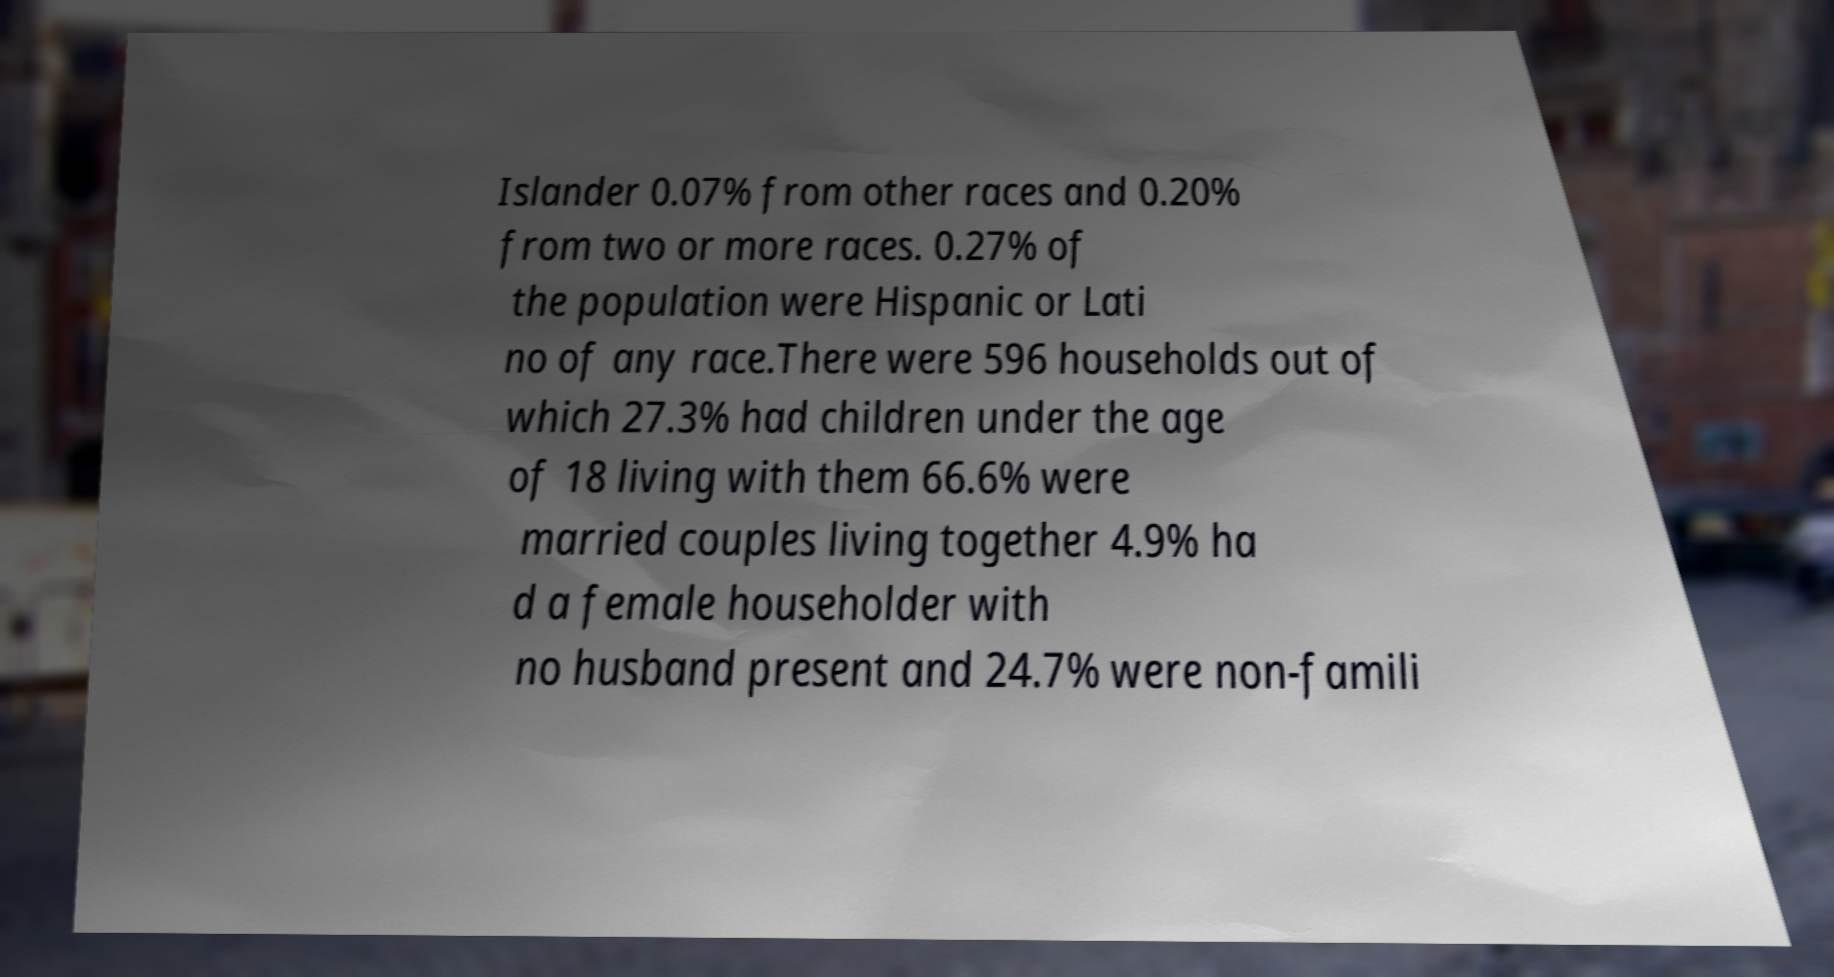Please identify and transcribe the text found in this image. Islander 0.07% from other races and 0.20% from two or more races. 0.27% of the population were Hispanic or Lati no of any race.There were 596 households out of which 27.3% had children under the age of 18 living with them 66.6% were married couples living together 4.9% ha d a female householder with no husband present and 24.7% were non-famili 